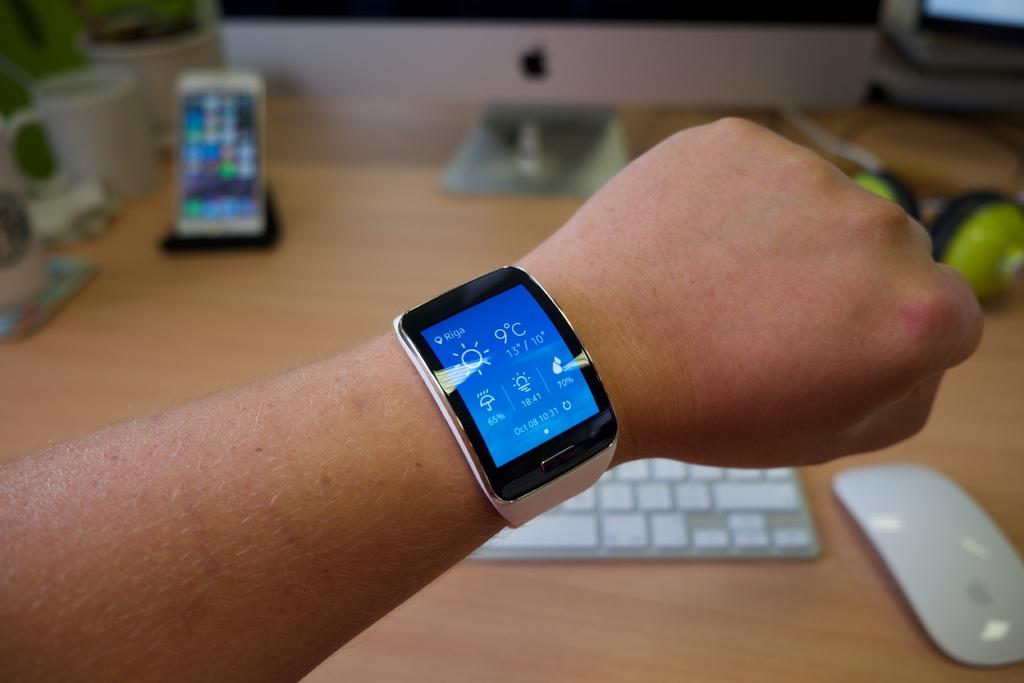<image>
Offer a succinct explanation of the picture presented. A person hold their wrist out displaying a smart watch being worn, with the location Riga, and the date of Oct 08, time 10:31. 